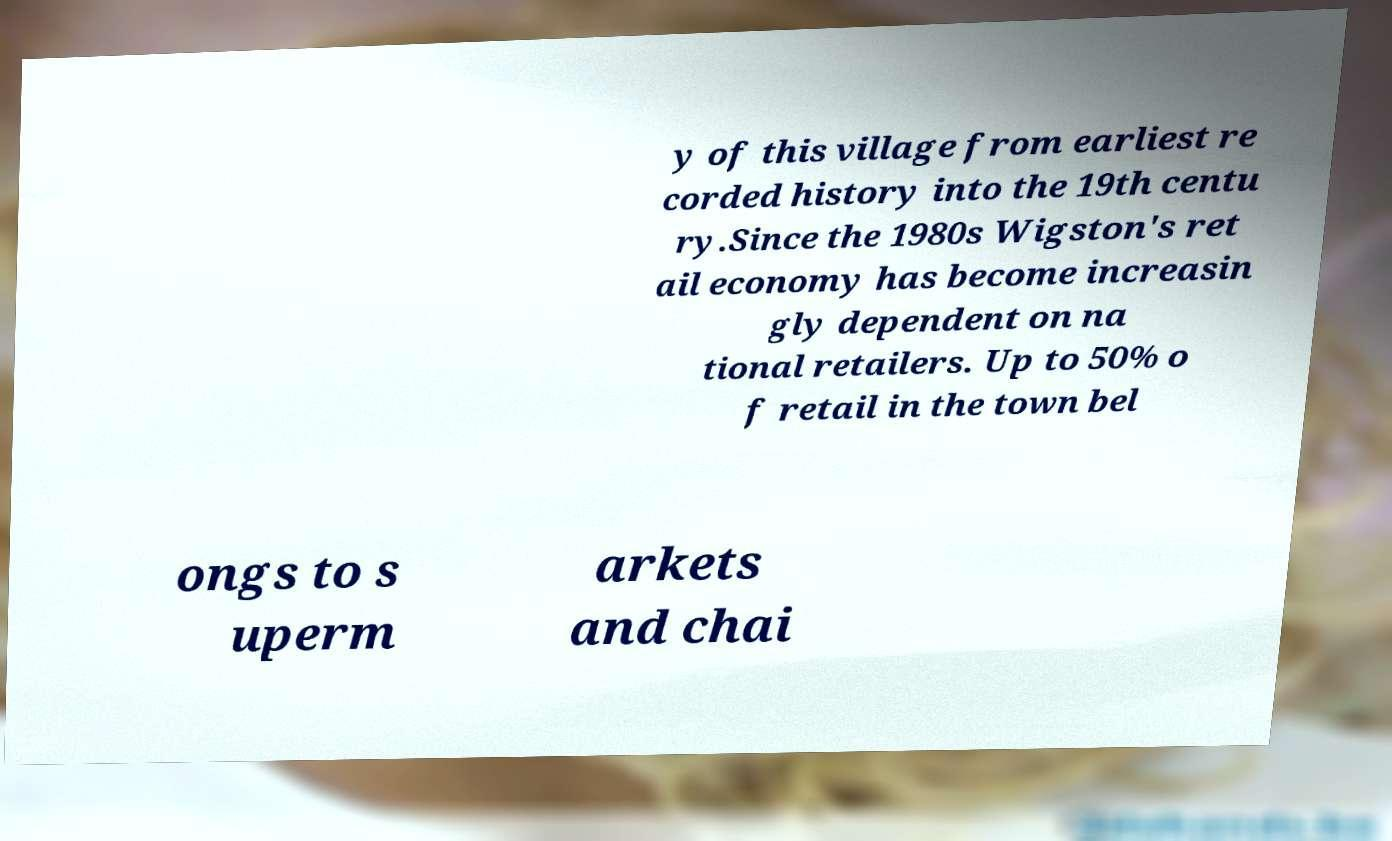Can you accurately transcribe the text from the provided image for me? y of this village from earliest re corded history into the 19th centu ry.Since the 1980s Wigston's ret ail economy has become increasin gly dependent on na tional retailers. Up to 50% o f retail in the town bel ongs to s uperm arkets and chai 